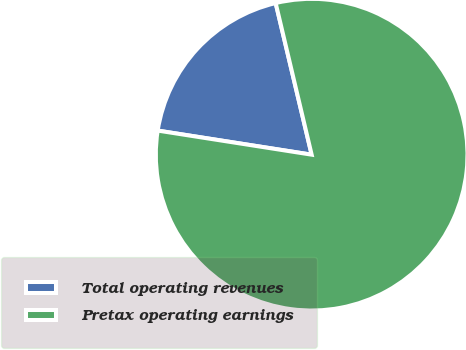<chart> <loc_0><loc_0><loc_500><loc_500><pie_chart><fcel>Total operating revenues<fcel>Pretax operating earnings<nl><fcel>18.82%<fcel>81.18%<nl></chart> 